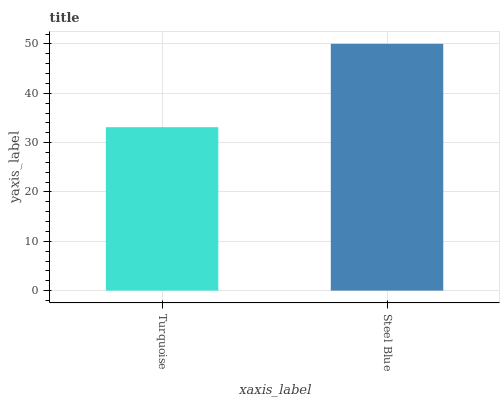Is Turquoise the minimum?
Answer yes or no. Yes. Is Steel Blue the maximum?
Answer yes or no. Yes. Is Steel Blue the minimum?
Answer yes or no. No. Is Steel Blue greater than Turquoise?
Answer yes or no. Yes. Is Turquoise less than Steel Blue?
Answer yes or no. Yes. Is Turquoise greater than Steel Blue?
Answer yes or no. No. Is Steel Blue less than Turquoise?
Answer yes or no. No. Is Steel Blue the high median?
Answer yes or no. Yes. Is Turquoise the low median?
Answer yes or no. Yes. Is Turquoise the high median?
Answer yes or no. No. Is Steel Blue the low median?
Answer yes or no. No. 